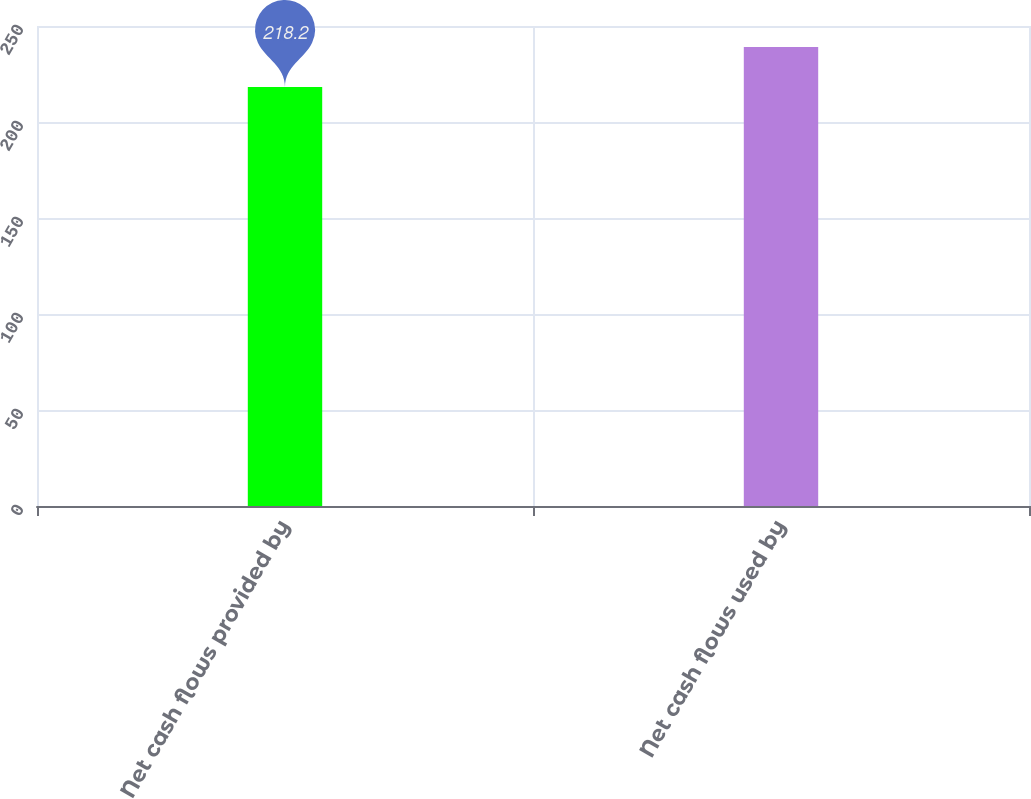<chart> <loc_0><loc_0><loc_500><loc_500><bar_chart><fcel>Net cash flows provided by<fcel>Net cash flows used by<nl><fcel>218.2<fcel>239<nl></chart> 